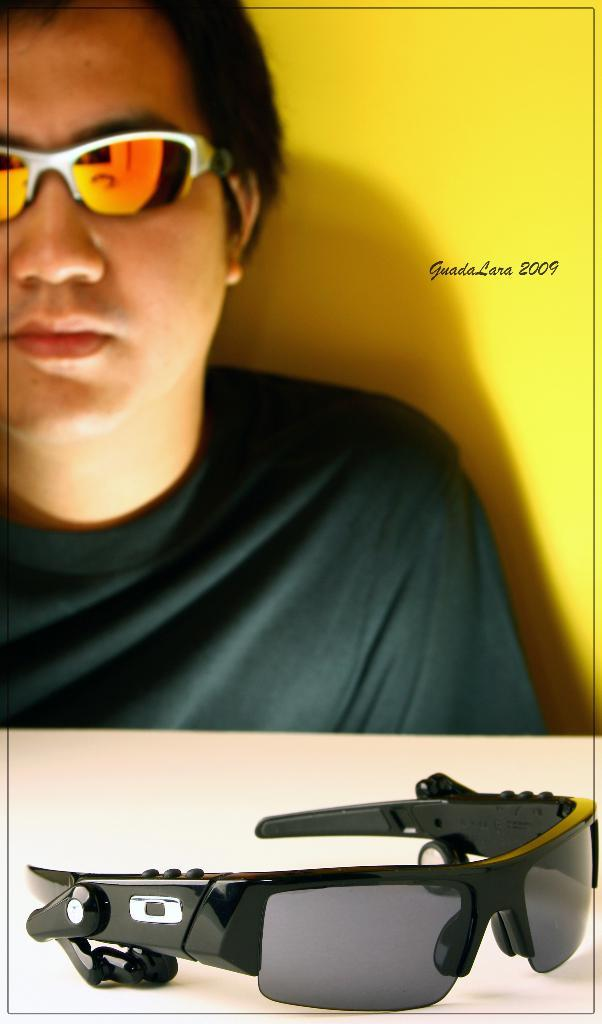Who is the main subject in the image? There is a man in the center of the image. What is the other prominent feature in the image? There is a Google logo or product in the image. What is the color of the surface the Google logo or product is placed on? The surface the Google logo or product is on is white in color. What type of cave is visible in the background of the image? There is no cave present in the image; it features a man and a Google logo or product on a white surface. 